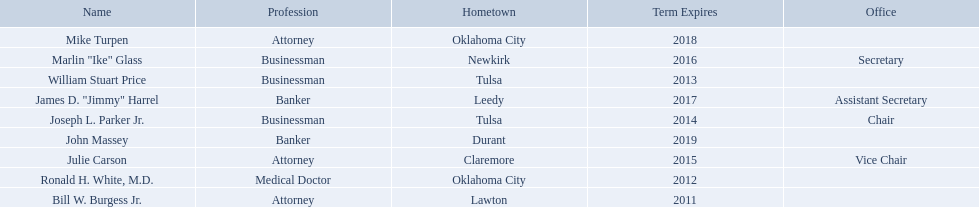What businessmen were born in tulsa? William Stuart Price, Joseph L. Parker Jr. Which man, other than price, was born in tulsa? Joseph L. Parker Jr. 